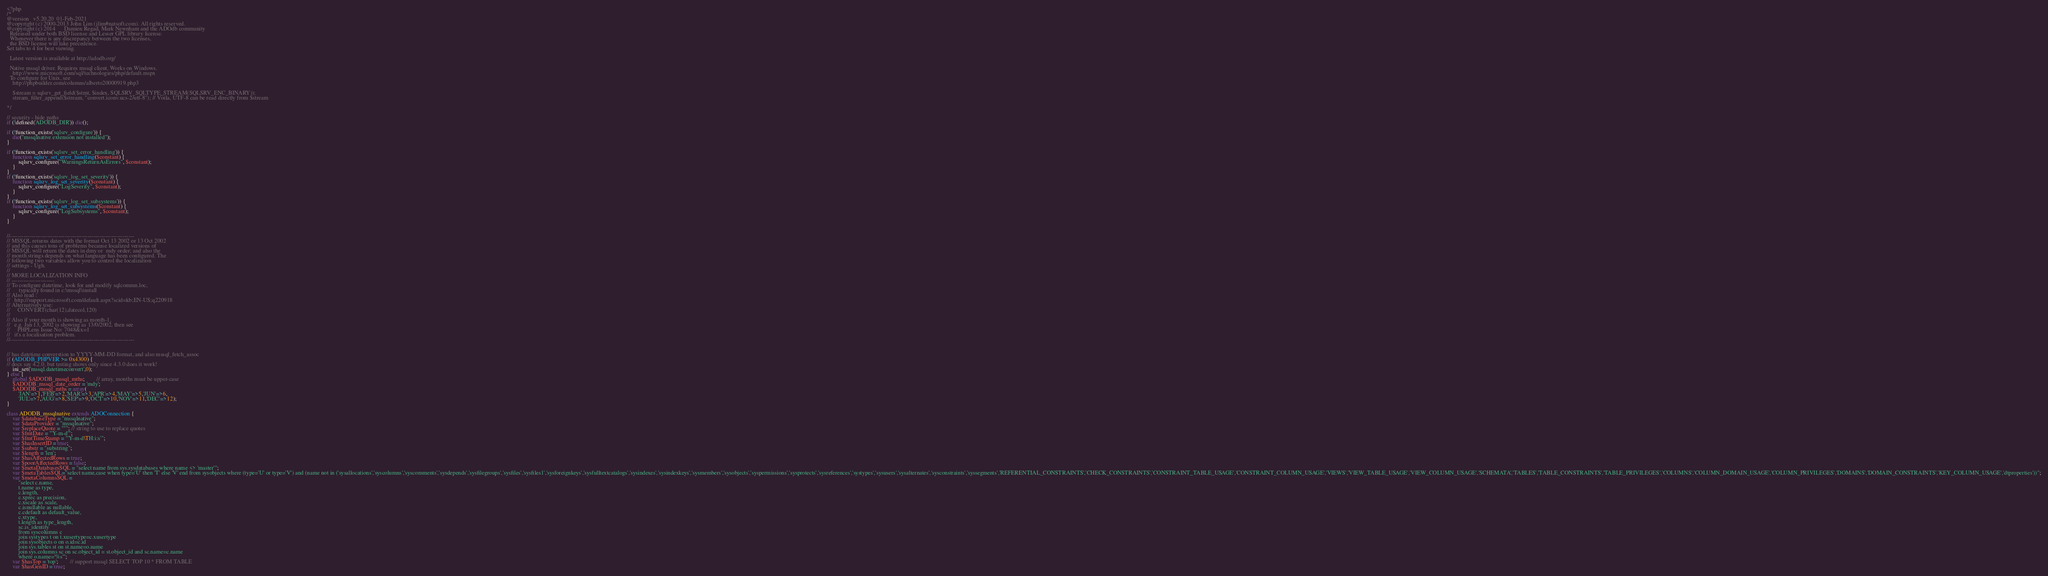<code> <loc_0><loc_0><loc_500><loc_500><_PHP_><?php
/*
@version   v5.20.20  01-Feb-2021
@copyright (c) 2000-2013 John Lim (jlim#natsoft.com). All rights reserved.
@copyright (c) 2014      Damien Regad, Mark Newnham and the ADOdb community
  Released under both BSD license and Lesser GPL library license.
  Whenever there is any discrepancy between the two licenses,
  the BSD license will take precedence.
Set tabs to 4 for best viewing.

  Latest version is available at http://adodb.org/

  Native mssql driver. Requires mssql client. Works on Windows.
    http://www.microsoft.com/sql/technologies/php/default.mspx
  To configure for Unix, see
   	http://phpbuilder.com/columns/alberto20000919.php3

    $stream = sqlsrv_get_field($stmt, $index, SQLSRV_SQLTYPE_STREAM(SQLSRV_ENC_BINARY));
    stream_filter_append($stream, "convert.iconv.ucs-2/utf-8"); // Voila, UTF-8 can be read directly from $stream

*/

// security - hide paths
if (!defined('ADODB_DIR')) die();

if (!function_exists('sqlsrv_configure')) {
	die("mssqlnative extension not installed");
}

if (!function_exists('sqlsrv_set_error_handling')) {
	function sqlsrv_set_error_handling($constant) {
		sqlsrv_configure("WarningsReturnAsErrors", $constant);
	}
}
if (!function_exists('sqlsrv_log_set_severity')) {
	function sqlsrv_log_set_severity($constant) {
		sqlsrv_configure("LogSeverity", $constant);
	}
}
if (!function_exists('sqlsrv_log_set_subsystems')) {
	function sqlsrv_log_set_subsystems($constant) {
		sqlsrv_configure("LogSubsystems", $constant);
	}
}


//----------------------------------------------------------------
// MSSQL returns dates with the format Oct 13 2002 or 13 Oct 2002
// and this causes tons of problems because localized versions of
// MSSQL will return the dates in dmy or  mdy order; and also the
// month strings depends on what language has been configured. The
// following two variables allow you to control the localization
// settings - Ugh.
//
// MORE LOCALIZATION INFO
// ----------------------
// To configure datetime, look for and modify sqlcommn.loc,
//  	typically found in c:\mssql\install
// Also read :
//	 http://support.microsoft.com/default.aspx?scid=kb;EN-US;q220918
// Alternatively use:
// 	   CONVERT(char(12),datecol,120)
//
// Also if your month is showing as month-1,
//   e.g. Jan 13, 2002 is showing as 13/0/2002, then see
//     PHPLens Issue No: 7048&x=1
//   it's a localisation problem.
//----------------------------------------------------------------


// has datetime converstion to YYYY-MM-DD format, and also mssql_fetch_assoc
if (ADODB_PHPVER >= 0x4300) {
// docs say 4.2.0, but testing shows only since 4.3.0 does it work!
	ini_set('mssql.datetimeconvert',0);
} else {
    global $ADODB_mssql_mths;		// array, months must be upper-case
	$ADODB_mssql_date_order = 'mdy';
	$ADODB_mssql_mths = array(
		'JAN'=>1,'FEB'=>2,'MAR'=>3,'APR'=>4,'MAY'=>5,'JUN'=>6,
		'JUL'=>7,'AUG'=>8,'SEP'=>9,'OCT'=>10,'NOV'=>11,'DEC'=>12);
}

class ADODB_mssqlnative extends ADOConnection {
	var $databaseType = "mssqlnative";
	var $dataProvider = "mssqlnative";
	var $replaceQuote = "''"; // string to use to replace quotes
	var $fmtDate = "'Y-m-d'";
	var $fmtTimeStamp = "'Y-m-d\TH:i:s'";
	var $hasInsertID = true;
	var $substr = "substring";
	var $length = 'len';
	var $hasAffectedRows = true;
	var $poorAffectedRows = false;
	var $metaDatabasesSQL = "select name from sys.sysdatabases where name <> 'master'";
	var $metaTablesSQL="select name,case when type='U' then 'T' else 'V' end from sysobjects where (type='U' or type='V') and (name not in ('sysallocations','syscolumns','syscomments','sysdepends','sysfilegroups','sysfiles','sysfiles1','sysforeignkeys','sysfulltextcatalogs','sysindexes','sysindexkeys','sysmembers','sysobjects','syspermissions','sysprotects','sysreferences','systypes','sysusers','sysalternates','sysconstraints','syssegments','REFERENTIAL_CONSTRAINTS','CHECK_CONSTRAINTS','CONSTRAINT_TABLE_USAGE','CONSTRAINT_COLUMN_USAGE','VIEWS','VIEW_TABLE_USAGE','VIEW_COLUMN_USAGE','SCHEMATA','TABLES','TABLE_CONSTRAINTS','TABLE_PRIVILEGES','COLUMNS','COLUMN_DOMAIN_USAGE','COLUMN_PRIVILEGES','DOMAINS','DOMAIN_CONSTRAINTS','KEY_COLUMN_USAGE','dtproperties'))";
	var $metaColumnsSQL =
		"select c.name,
		t.name as type,
		c.length,
		c.xprec as precision,
		c.xscale as scale,
		c.isnullable as nullable,
		c.cdefault as default_value,
		c.xtype,
		t.length as type_length,
		sc.is_identity
		from syscolumns c
		join systypes t on t.xusertype=c.xusertype
		join sysobjects o on o.id=c.id
		join sys.tables st on st.name=o.name
		join sys.columns sc on sc.object_id = st.object_id and sc.name=c.name
		where o.name='%s'";
	var $hasTop = 'top';		// support mssql SELECT TOP 10 * FROM TABLE
	var $hasGenID = true;</code> 